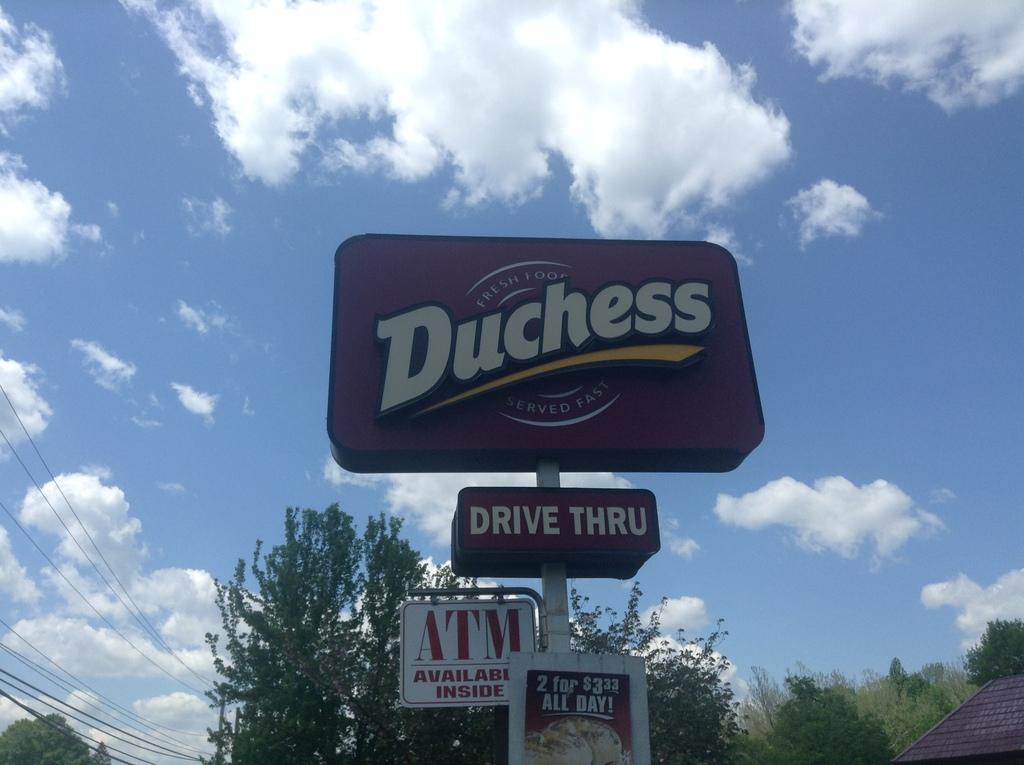<image>
Present a compact description of the photo's key features. A sign for a restaurant claims there is an ATM inside. 